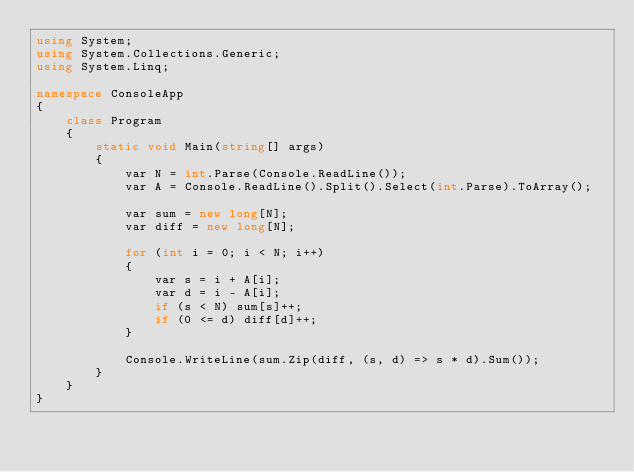Convert code to text. <code><loc_0><loc_0><loc_500><loc_500><_C#_>using System;
using System.Collections.Generic;
using System.Linq;

namespace ConsoleApp
{
    class Program
    {
        static void Main(string[] args)
        {
            var N = int.Parse(Console.ReadLine());
            var A = Console.ReadLine().Split().Select(int.Parse).ToArray();

            var sum = new long[N];
            var diff = new long[N];

            for (int i = 0; i < N; i++)
            {
                var s = i + A[i];
                var d = i - A[i];
                if (s < N) sum[s]++;
                if (0 <= d) diff[d]++;
            }

            Console.WriteLine(sum.Zip(diff, (s, d) => s * d).Sum());
        }
    }
}
</code> 